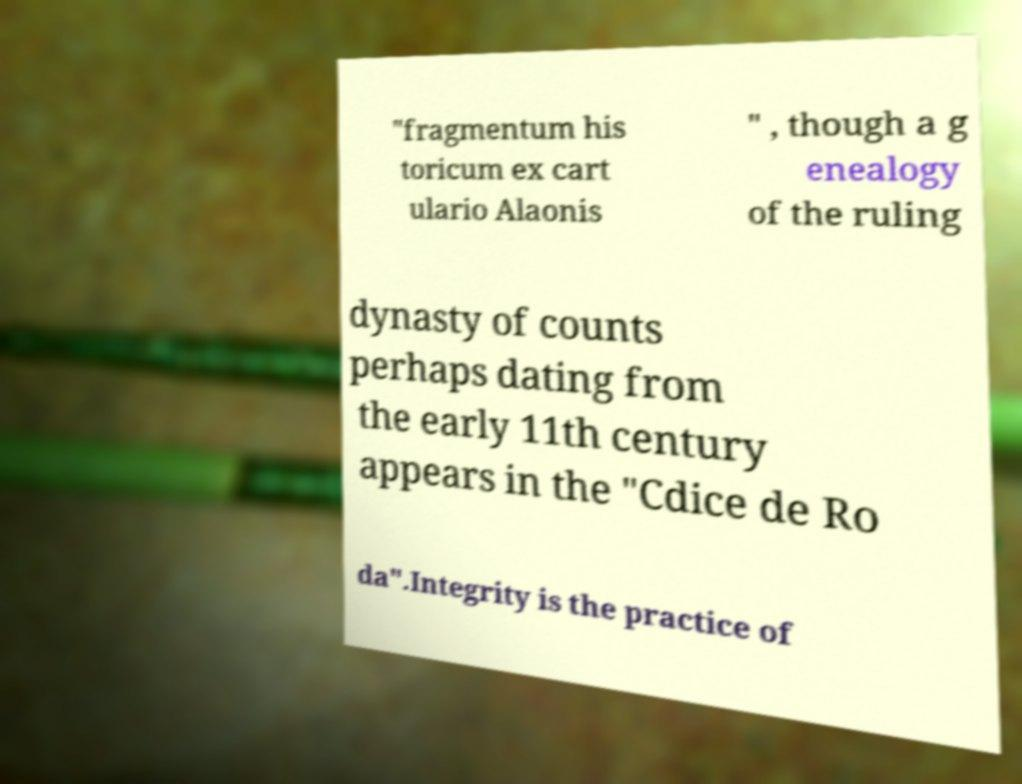Could you assist in decoding the text presented in this image and type it out clearly? "fragmentum his toricum ex cart ulario Alaonis " , though a g enealogy of the ruling dynasty of counts perhaps dating from the early 11th century appears in the "Cdice de Ro da".Integrity is the practice of 